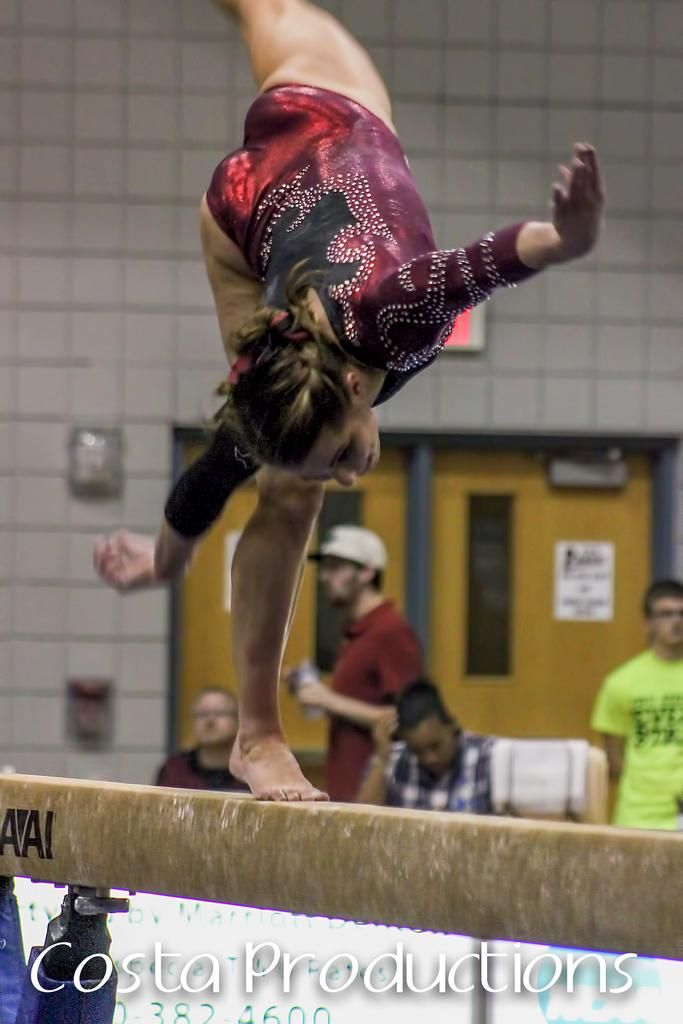Who is the main subject in the image? There is a lady in the image. What is the lady standing on? The lady is standing on a wooden object. What can be seen in the background of the image? There are people, a wall, and other objects visible in the background of the image. What type of sand can be seen in the image? There is no sand present in the image. Can you see any magic happening in the image? There is no magic happening in the image. 